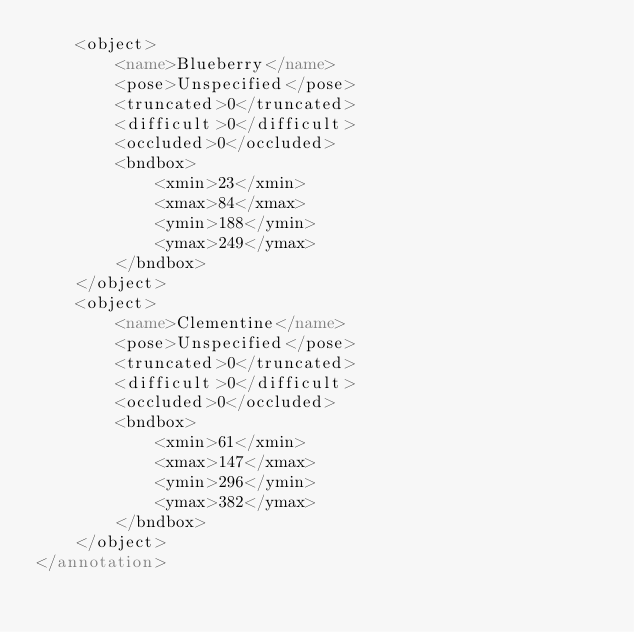Convert code to text. <code><loc_0><loc_0><loc_500><loc_500><_XML_>	<object>
		<name>Blueberry</name>
		<pose>Unspecified</pose>
		<truncated>0</truncated>
		<difficult>0</difficult>
		<occluded>0</occluded>
		<bndbox>
			<xmin>23</xmin>
			<xmax>84</xmax>
			<ymin>188</ymin>
			<ymax>249</ymax>
		</bndbox>
	</object>
	<object>
		<name>Clementine</name>
		<pose>Unspecified</pose>
		<truncated>0</truncated>
		<difficult>0</difficult>
		<occluded>0</occluded>
		<bndbox>
			<xmin>61</xmin>
			<xmax>147</xmax>
			<ymin>296</ymin>
			<ymax>382</ymax>
		</bndbox>
	</object>
</annotation>
</code> 